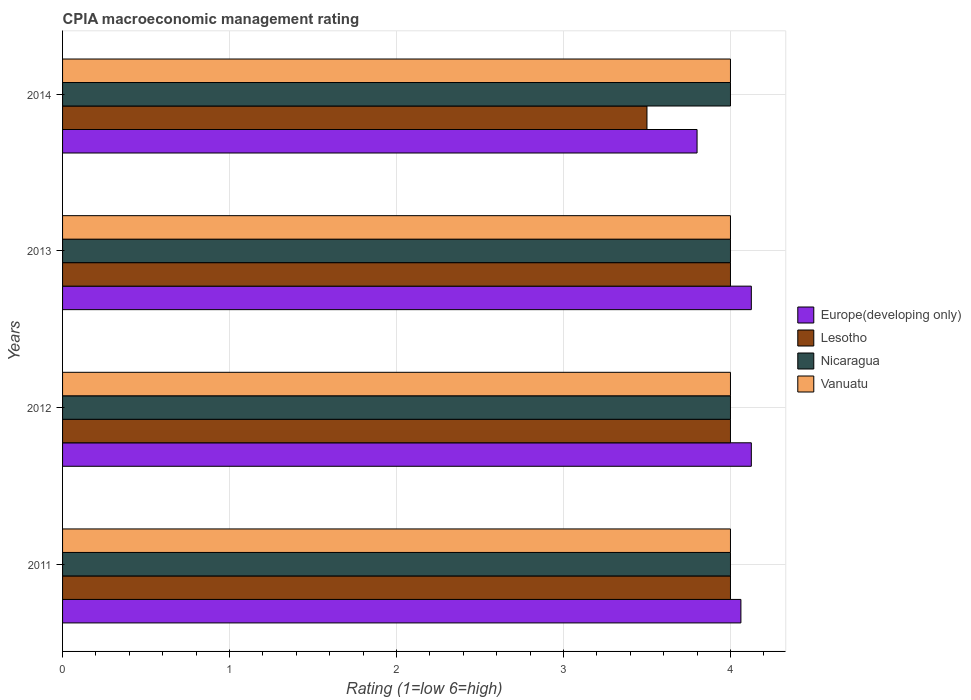How many bars are there on the 3rd tick from the top?
Offer a very short reply. 4. What is the CPIA rating in Europe(developing only) in 2011?
Ensure brevity in your answer.  4.06. Across all years, what is the minimum CPIA rating in Lesotho?
Your answer should be very brief. 3.5. In which year was the CPIA rating in Vanuatu maximum?
Keep it short and to the point. 2011. In which year was the CPIA rating in Europe(developing only) minimum?
Your answer should be compact. 2014. What is the ratio of the CPIA rating in Europe(developing only) in 2011 to that in 2013?
Provide a succinct answer. 0.98. What is the difference between the highest and the second highest CPIA rating in Europe(developing only)?
Make the answer very short. 0. What does the 4th bar from the top in 2011 represents?
Your response must be concise. Europe(developing only). What does the 1st bar from the bottom in 2013 represents?
Your answer should be very brief. Europe(developing only). How many bars are there?
Make the answer very short. 16. Does the graph contain grids?
Your answer should be compact. Yes. Where does the legend appear in the graph?
Provide a short and direct response. Center right. How many legend labels are there?
Keep it short and to the point. 4. What is the title of the graph?
Provide a short and direct response. CPIA macroeconomic management rating. What is the label or title of the Y-axis?
Provide a succinct answer. Years. What is the Rating (1=low 6=high) of Europe(developing only) in 2011?
Make the answer very short. 4.06. What is the Rating (1=low 6=high) in Lesotho in 2011?
Provide a succinct answer. 4. What is the Rating (1=low 6=high) in Nicaragua in 2011?
Your response must be concise. 4. What is the Rating (1=low 6=high) of Vanuatu in 2011?
Your answer should be compact. 4. What is the Rating (1=low 6=high) in Europe(developing only) in 2012?
Your answer should be very brief. 4.12. What is the Rating (1=low 6=high) of Vanuatu in 2012?
Give a very brief answer. 4. What is the Rating (1=low 6=high) in Europe(developing only) in 2013?
Ensure brevity in your answer.  4.12. What is the Rating (1=low 6=high) of Nicaragua in 2013?
Your response must be concise. 4. What is the Rating (1=low 6=high) of Europe(developing only) in 2014?
Your answer should be compact. 3.8. What is the Rating (1=low 6=high) in Lesotho in 2014?
Your answer should be compact. 3.5. Across all years, what is the maximum Rating (1=low 6=high) of Europe(developing only)?
Your answer should be very brief. 4.12. Across all years, what is the maximum Rating (1=low 6=high) in Nicaragua?
Your answer should be compact. 4. Across all years, what is the minimum Rating (1=low 6=high) in Lesotho?
Ensure brevity in your answer.  3.5. Across all years, what is the minimum Rating (1=low 6=high) of Vanuatu?
Provide a short and direct response. 4. What is the total Rating (1=low 6=high) in Europe(developing only) in the graph?
Your answer should be compact. 16.11. What is the total Rating (1=low 6=high) in Nicaragua in the graph?
Ensure brevity in your answer.  16. What is the total Rating (1=low 6=high) in Vanuatu in the graph?
Give a very brief answer. 16. What is the difference between the Rating (1=low 6=high) of Europe(developing only) in 2011 and that in 2012?
Provide a succinct answer. -0.06. What is the difference between the Rating (1=low 6=high) of Lesotho in 2011 and that in 2012?
Offer a very short reply. 0. What is the difference between the Rating (1=low 6=high) in Europe(developing only) in 2011 and that in 2013?
Provide a short and direct response. -0.06. What is the difference between the Rating (1=low 6=high) in Lesotho in 2011 and that in 2013?
Give a very brief answer. 0. What is the difference between the Rating (1=low 6=high) in Vanuatu in 2011 and that in 2013?
Your answer should be very brief. 0. What is the difference between the Rating (1=low 6=high) of Europe(developing only) in 2011 and that in 2014?
Make the answer very short. 0.26. What is the difference between the Rating (1=low 6=high) of Lesotho in 2011 and that in 2014?
Your answer should be very brief. 0.5. What is the difference between the Rating (1=low 6=high) of Nicaragua in 2011 and that in 2014?
Keep it short and to the point. 0. What is the difference between the Rating (1=low 6=high) of Europe(developing only) in 2012 and that in 2013?
Your answer should be very brief. 0. What is the difference between the Rating (1=low 6=high) of Lesotho in 2012 and that in 2013?
Offer a very short reply. 0. What is the difference between the Rating (1=low 6=high) in Nicaragua in 2012 and that in 2013?
Ensure brevity in your answer.  0. What is the difference between the Rating (1=low 6=high) in Europe(developing only) in 2012 and that in 2014?
Offer a terse response. 0.33. What is the difference between the Rating (1=low 6=high) in Europe(developing only) in 2013 and that in 2014?
Make the answer very short. 0.33. What is the difference between the Rating (1=low 6=high) in Nicaragua in 2013 and that in 2014?
Ensure brevity in your answer.  0. What is the difference between the Rating (1=low 6=high) of Europe(developing only) in 2011 and the Rating (1=low 6=high) of Lesotho in 2012?
Your answer should be very brief. 0.06. What is the difference between the Rating (1=low 6=high) of Europe(developing only) in 2011 and the Rating (1=low 6=high) of Nicaragua in 2012?
Give a very brief answer. 0.06. What is the difference between the Rating (1=low 6=high) of Europe(developing only) in 2011 and the Rating (1=low 6=high) of Vanuatu in 2012?
Your answer should be very brief. 0.06. What is the difference between the Rating (1=low 6=high) in Lesotho in 2011 and the Rating (1=low 6=high) in Nicaragua in 2012?
Your answer should be very brief. 0. What is the difference between the Rating (1=low 6=high) in Europe(developing only) in 2011 and the Rating (1=low 6=high) in Lesotho in 2013?
Your answer should be very brief. 0.06. What is the difference between the Rating (1=low 6=high) of Europe(developing only) in 2011 and the Rating (1=low 6=high) of Nicaragua in 2013?
Provide a short and direct response. 0.06. What is the difference between the Rating (1=low 6=high) in Europe(developing only) in 2011 and the Rating (1=low 6=high) in Vanuatu in 2013?
Your response must be concise. 0.06. What is the difference between the Rating (1=low 6=high) of Nicaragua in 2011 and the Rating (1=low 6=high) of Vanuatu in 2013?
Give a very brief answer. 0. What is the difference between the Rating (1=low 6=high) in Europe(developing only) in 2011 and the Rating (1=low 6=high) in Lesotho in 2014?
Give a very brief answer. 0.56. What is the difference between the Rating (1=low 6=high) in Europe(developing only) in 2011 and the Rating (1=low 6=high) in Nicaragua in 2014?
Provide a short and direct response. 0.06. What is the difference between the Rating (1=low 6=high) in Europe(developing only) in 2011 and the Rating (1=low 6=high) in Vanuatu in 2014?
Ensure brevity in your answer.  0.06. What is the difference between the Rating (1=low 6=high) in Nicaragua in 2011 and the Rating (1=low 6=high) in Vanuatu in 2014?
Provide a succinct answer. 0. What is the difference between the Rating (1=low 6=high) of Lesotho in 2012 and the Rating (1=low 6=high) of Nicaragua in 2013?
Keep it short and to the point. 0. What is the difference between the Rating (1=low 6=high) of Nicaragua in 2012 and the Rating (1=low 6=high) of Vanuatu in 2013?
Your response must be concise. 0. What is the difference between the Rating (1=low 6=high) of Europe(developing only) in 2012 and the Rating (1=low 6=high) of Lesotho in 2014?
Give a very brief answer. 0.62. What is the difference between the Rating (1=low 6=high) of Europe(developing only) in 2012 and the Rating (1=low 6=high) of Nicaragua in 2014?
Give a very brief answer. 0.12. What is the difference between the Rating (1=low 6=high) in Europe(developing only) in 2012 and the Rating (1=low 6=high) in Vanuatu in 2014?
Offer a very short reply. 0.12. What is the difference between the Rating (1=low 6=high) of Nicaragua in 2012 and the Rating (1=low 6=high) of Vanuatu in 2014?
Provide a short and direct response. 0. What is the difference between the Rating (1=low 6=high) in Europe(developing only) in 2013 and the Rating (1=low 6=high) in Lesotho in 2014?
Your answer should be very brief. 0.62. What is the difference between the Rating (1=low 6=high) in Europe(developing only) in 2013 and the Rating (1=low 6=high) in Nicaragua in 2014?
Offer a terse response. 0.12. What is the difference between the Rating (1=low 6=high) of Lesotho in 2013 and the Rating (1=low 6=high) of Nicaragua in 2014?
Make the answer very short. 0. What is the difference between the Rating (1=low 6=high) in Lesotho in 2013 and the Rating (1=low 6=high) in Vanuatu in 2014?
Keep it short and to the point. 0. What is the difference between the Rating (1=low 6=high) of Nicaragua in 2013 and the Rating (1=low 6=high) of Vanuatu in 2014?
Your answer should be compact. 0. What is the average Rating (1=low 6=high) in Europe(developing only) per year?
Ensure brevity in your answer.  4.03. What is the average Rating (1=low 6=high) in Lesotho per year?
Provide a succinct answer. 3.88. What is the average Rating (1=low 6=high) in Nicaragua per year?
Provide a short and direct response. 4. In the year 2011, what is the difference between the Rating (1=low 6=high) in Europe(developing only) and Rating (1=low 6=high) in Lesotho?
Keep it short and to the point. 0.06. In the year 2011, what is the difference between the Rating (1=low 6=high) in Europe(developing only) and Rating (1=low 6=high) in Nicaragua?
Give a very brief answer. 0.06. In the year 2011, what is the difference between the Rating (1=low 6=high) in Europe(developing only) and Rating (1=low 6=high) in Vanuatu?
Your answer should be very brief. 0.06. In the year 2011, what is the difference between the Rating (1=low 6=high) in Lesotho and Rating (1=low 6=high) in Nicaragua?
Make the answer very short. 0. In the year 2011, what is the difference between the Rating (1=low 6=high) in Lesotho and Rating (1=low 6=high) in Vanuatu?
Make the answer very short. 0. In the year 2012, what is the difference between the Rating (1=low 6=high) of Europe(developing only) and Rating (1=low 6=high) of Lesotho?
Offer a very short reply. 0.12. In the year 2012, what is the difference between the Rating (1=low 6=high) of Europe(developing only) and Rating (1=low 6=high) of Vanuatu?
Provide a short and direct response. 0.12. In the year 2013, what is the difference between the Rating (1=low 6=high) of Europe(developing only) and Rating (1=low 6=high) of Lesotho?
Offer a very short reply. 0.12. In the year 2013, what is the difference between the Rating (1=low 6=high) in Lesotho and Rating (1=low 6=high) in Nicaragua?
Keep it short and to the point. 0. In the year 2013, what is the difference between the Rating (1=low 6=high) in Lesotho and Rating (1=low 6=high) in Vanuatu?
Offer a terse response. 0. In the year 2013, what is the difference between the Rating (1=low 6=high) in Nicaragua and Rating (1=low 6=high) in Vanuatu?
Keep it short and to the point. 0. In the year 2014, what is the difference between the Rating (1=low 6=high) in Europe(developing only) and Rating (1=low 6=high) in Lesotho?
Offer a terse response. 0.3. In the year 2014, what is the difference between the Rating (1=low 6=high) of Europe(developing only) and Rating (1=low 6=high) of Nicaragua?
Provide a short and direct response. -0.2. In the year 2014, what is the difference between the Rating (1=low 6=high) of Europe(developing only) and Rating (1=low 6=high) of Vanuatu?
Keep it short and to the point. -0.2. In the year 2014, what is the difference between the Rating (1=low 6=high) in Lesotho and Rating (1=low 6=high) in Nicaragua?
Provide a short and direct response. -0.5. In the year 2014, what is the difference between the Rating (1=low 6=high) in Lesotho and Rating (1=low 6=high) in Vanuatu?
Give a very brief answer. -0.5. In the year 2014, what is the difference between the Rating (1=low 6=high) of Nicaragua and Rating (1=low 6=high) of Vanuatu?
Offer a very short reply. 0. What is the ratio of the Rating (1=low 6=high) of Lesotho in 2011 to that in 2012?
Make the answer very short. 1. What is the ratio of the Rating (1=low 6=high) of Nicaragua in 2011 to that in 2012?
Your answer should be very brief. 1. What is the ratio of the Rating (1=low 6=high) of Vanuatu in 2011 to that in 2012?
Provide a succinct answer. 1. What is the ratio of the Rating (1=low 6=high) of Nicaragua in 2011 to that in 2013?
Make the answer very short. 1. What is the ratio of the Rating (1=low 6=high) in Vanuatu in 2011 to that in 2013?
Provide a short and direct response. 1. What is the ratio of the Rating (1=low 6=high) of Europe(developing only) in 2011 to that in 2014?
Provide a short and direct response. 1.07. What is the ratio of the Rating (1=low 6=high) of Vanuatu in 2011 to that in 2014?
Your answer should be compact. 1. What is the ratio of the Rating (1=low 6=high) in Europe(developing only) in 2012 to that in 2013?
Ensure brevity in your answer.  1. What is the ratio of the Rating (1=low 6=high) of Lesotho in 2012 to that in 2013?
Make the answer very short. 1. What is the ratio of the Rating (1=low 6=high) in Nicaragua in 2012 to that in 2013?
Provide a succinct answer. 1. What is the ratio of the Rating (1=low 6=high) of Vanuatu in 2012 to that in 2013?
Keep it short and to the point. 1. What is the ratio of the Rating (1=low 6=high) of Europe(developing only) in 2012 to that in 2014?
Your answer should be compact. 1.09. What is the ratio of the Rating (1=low 6=high) in Lesotho in 2012 to that in 2014?
Your answer should be very brief. 1.14. What is the ratio of the Rating (1=low 6=high) in Nicaragua in 2012 to that in 2014?
Offer a terse response. 1. What is the ratio of the Rating (1=low 6=high) of Europe(developing only) in 2013 to that in 2014?
Offer a terse response. 1.09. What is the ratio of the Rating (1=low 6=high) of Lesotho in 2013 to that in 2014?
Give a very brief answer. 1.14. What is the ratio of the Rating (1=low 6=high) of Nicaragua in 2013 to that in 2014?
Provide a succinct answer. 1. What is the difference between the highest and the second highest Rating (1=low 6=high) in Lesotho?
Your answer should be compact. 0. What is the difference between the highest and the second highest Rating (1=low 6=high) in Vanuatu?
Make the answer very short. 0. What is the difference between the highest and the lowest Rating (1=low 6=high) of Europe(developing only)?
Make the answer very short. 0.33. What is the difference between the highest and the lowest Rating (1=low 6=high) of Nicaragua?
Provide a succinct answer. 0. What is the difference between the highest and the lowest Rating (1=low 6=high) of Vanuatu?
Your answer should be very brief. 0. 